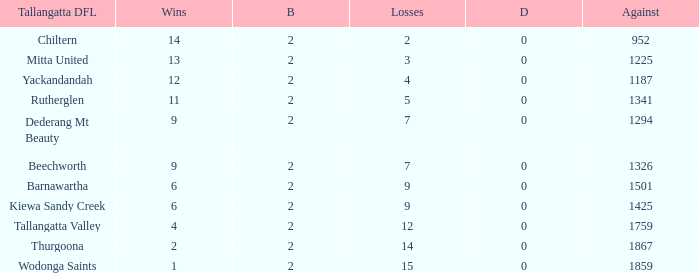What are the fewest draws with less than 7 losses and Mitta United is the Tallagatta DFL? 0.0. 